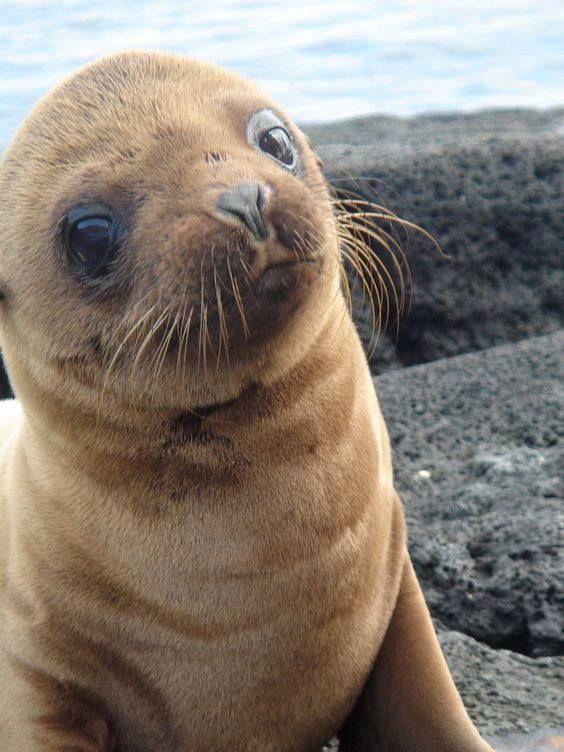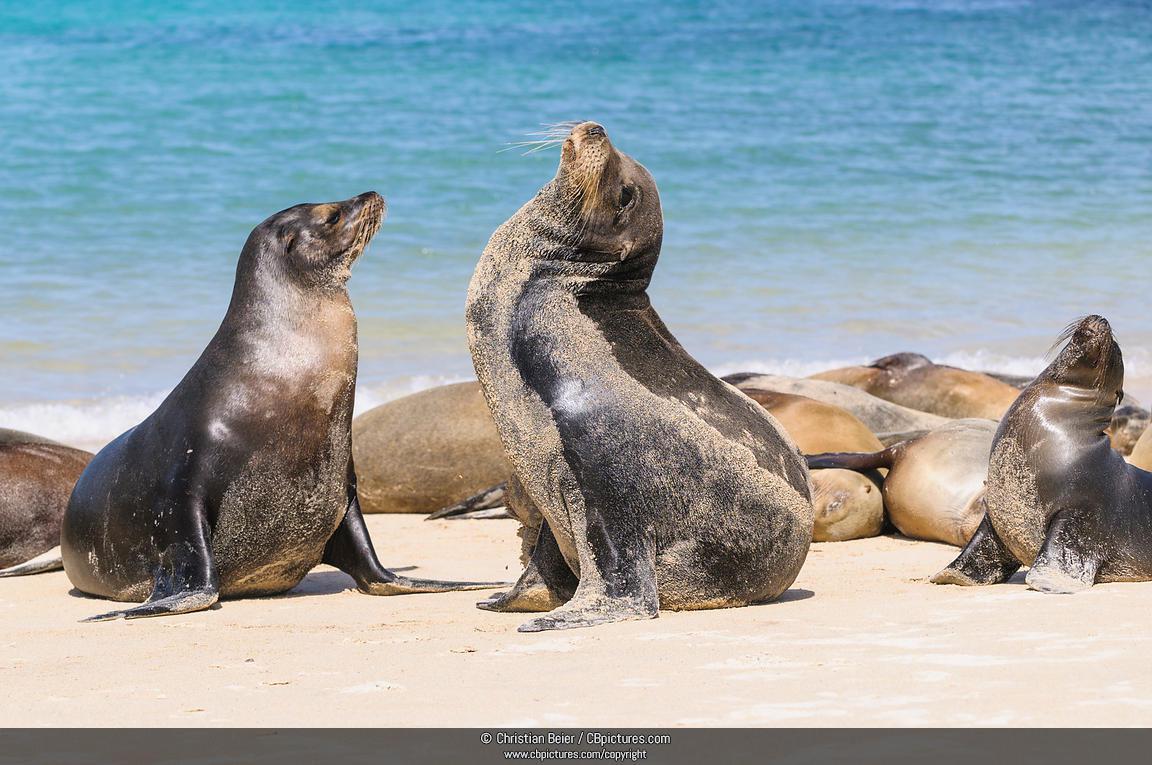The first image is the image on the left, the second image is the image on the right. Given the left and right images, does the statement "The left and right image contains the same number of sea lions." hold true? Answer yes or no. No. The first image is the image on the left, the second image is the image on the right. For the images displayed, is the sentence "The right image contains exactly two seals." factually correct? Answer yes or no. No. 